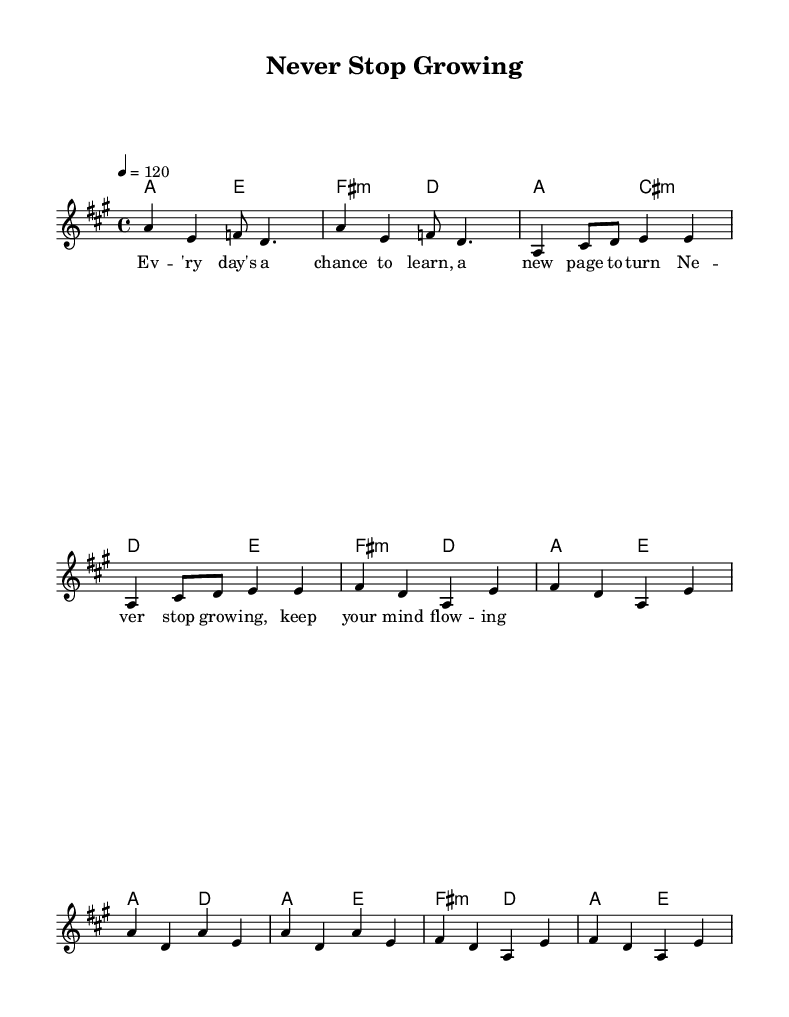What is the key signature of this music? The key signature is A major, which has three sharps (F#, C#, and G#). The presence of these sharps is indicated at the beginning of the staff.
Answer: A major What is the time signature of this music? The time signature is 4/4, which means there are four beats in each measure and the quarter note gets one beat. This is indicated at the beginning of the staff.
Answer: 4/4 What is the tempo marking for this piece? The tempo marking is 120 beats per minute, indicated by the tempo directive "4 = 120" at the beginning of the piece. This indicates the speed of the music.
Answer: 120 How many measures are there in the chorus section? The chorus section consists of four measures, which can be counted from the corresponding section of the music that is labeled and structured accordingly.
Answer: 4 What is the main lyrical theme of the song? The main lyrical theme focuses on the concept of continuous learning and growth, as reflected in the chorus words "Never stop growing, keep your mind flowing". This theme is conveyed throughout the lyrics.
Answer: Lifelong learning What chord follows the first measure of the verse? The chord that follows the first measure of the verse is C# minor, indicated by the chord symbol provided in the harmony section. This is directly seen in the music notation.
Answer: C# minor What is the function of the refrain in Disco music? The refrain (or chorus) in Disco music typically serves to repeat the central message, amplifying its catchiness and emotional impact, as seen in this piece which centers on personal growth and learning. This can be understood from the structure and lyrics.
Answer: Central message 